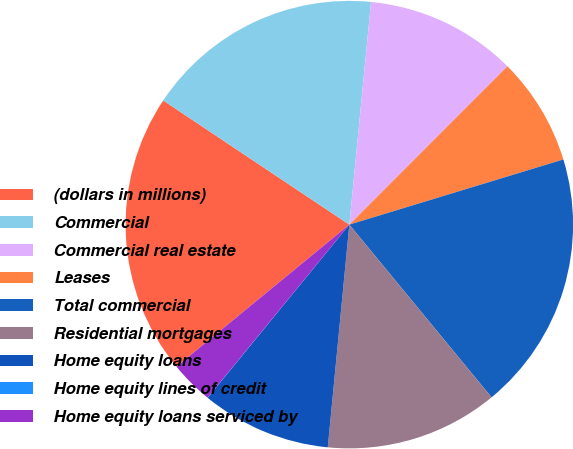Convert chart. <chart><loc_0><loc_0><loc_500><loc_500><pie_chart><fcel>(dollars in millions)<fcel>Commercial<fcel>Commercial real estate<fcel>Leases<fcel>Total commercial<fcel>Residential mortgages<fcel>Home equity loans<fcel>Home equity lines of credit<fcel>Home equity loans serviced by<nl><fcel>20.31%<fcel>17.18%<fcel>10.94%<fcel>7.81%<fcel>18.74%<fcel>12.5%<fcel>9.38%<fcel>0.01%<fcel>3.13%<nl></chart> 